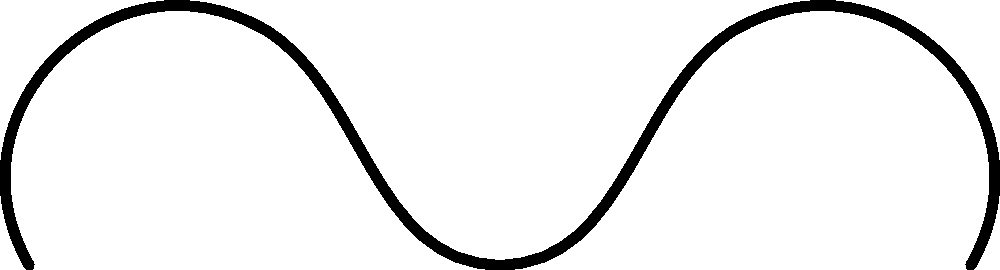In the diagram above, which structural feature of the enzyme is crucial for its specificity in nutrient breakdown, and how does it relate to the enzyme's function in patients with nutrient absorption disorders? To answer this question, let's break down the key components of enzyme structure and function:

1. Enzyme structure: The diagram shows a simplified representation of an enzyme with its characteristic folded shape.

2. Active site: The red region in the diagram represents the active site of the enzyme. This is the most crucial feature for enzyme specificity.

3. Substrate: The blue structure represents the substrate, which is the nutrient molecule that the enzyme will break down.

4. Enzyme-substrate interaction: The active site is shaped to fit the specific substrate molecule, following the "lock and key" or "induced fit" model.

5. Specificity: The shape of the active site determines which substrates the enzyme can bind to and catalyze, providing specificity in nutrient breakdown.

6. Relation to nutrient absorption disorders: In patients with genetic disorders affecting nutrient absorption, the enzymes responsible for breaking down specific nutrients may have altered active sites due to mutations. This can lead to:
   a) Reduced binding efficiency of the substrate
   b) Decreased catalytic activity
   c) Inability to break down certain nutrients effectively

7. Consequences: These enzyme deficiencies can result in malabsorption of specific nutrients, leading to various health issues associated with the particular genetic disorder.

Therefore, the active site is the crucial structural feature for enzyme specificity in nutrient breakdown, and its altered shape or function in genetic disorders can significantly impact nutrient absorption.
Answer: Active site 